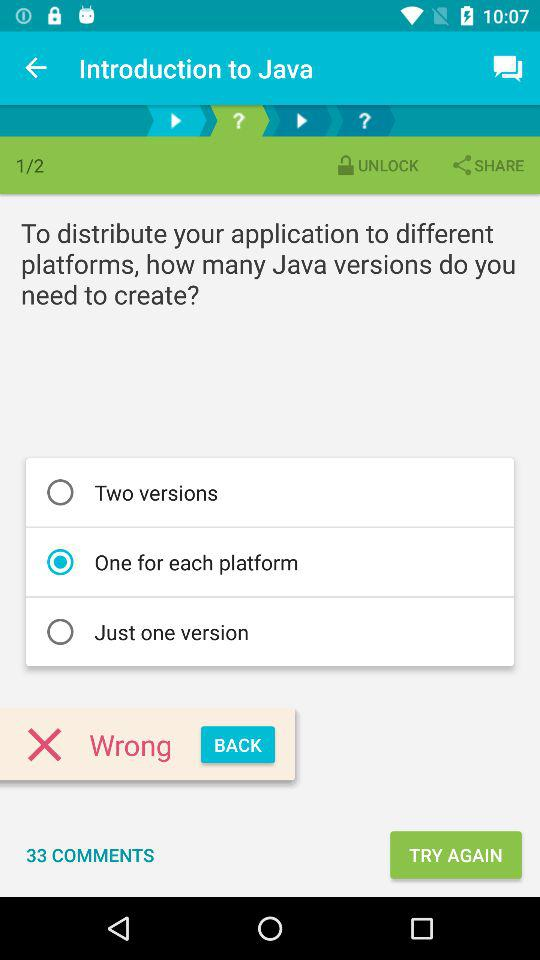Which page number is the person currently on? The person is currently on page 1. 